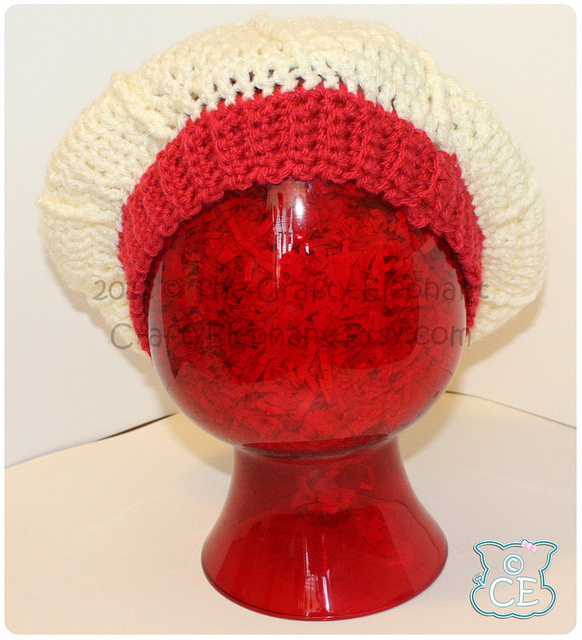Describe the objects in this image and their specific colors. I can see a vase in white, brown, and maroon tones in this image. 